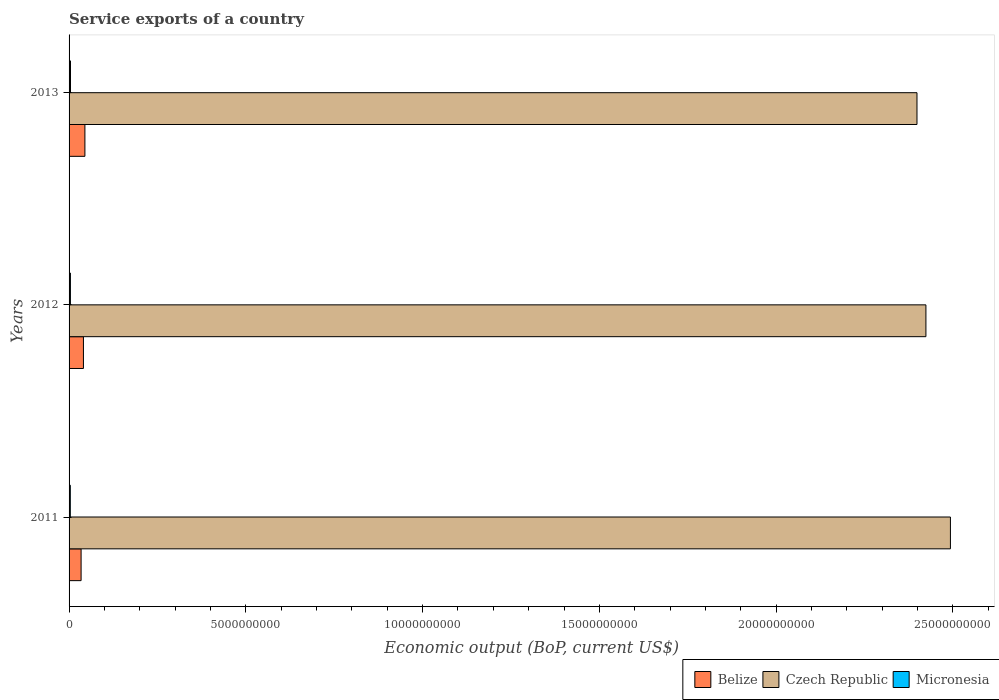How many different coloured bars are there?
Your answer should be very brief. 3. How many groups of bars are there?
Offer a very short reply. 3. Are the number of bars per tick equal to the number of legend labels?
Keep it short and to the point. Yes. Are the number of bars on each tick of the Y-axis equal?
Your answer should be compact. Yes. What is the service exports in Czech Republic in 2011?
Offer a very short reply. 2.49e+1. Across all years, what is the maximum service exports in Czech Republic?
Provide a short and direct response. 2.49e+1. Across all years, what is the minimum service exports in Czech Republic?
Your answer should be very brief. 2.40e+1. What is the total service exports in Micronesia in the graph?
Provide a succinct answer. 1.14e+08. What is the difference between the service exports in Micronesia in 2011 and that in 2012?
Provide a succinct answer. -3.22e+06. What is the difference between the service exports in Micronesia in 2011 and the service exports in Belize in 2013?
Offer a very short reply. -4.13e+08. What is the average service exports in Belize per year?
Your answer should be compact. 3.98e+08. In the year 2011, what is the difference between the service exports in Czech Republic and service exports in Belize?
Your response must be concise. 2.46e+1. In how many years, is the service exports in Czech Republic greater than 2000000000 US$?
Provide a succinct answer. 3. What is the ratio of the service exports in Belize in 2012 to that in 2013?
Provide a succinct answer. 0.91. Is the difference between the service exports in Czech Republic in 2012 and 2013 greater than the difference between the service exports in Belize in 2012 and 2013?
Offer a very short reply. Yes. What is the difference between the highest and the second highest service exports in Czech Republic?
Offer a terse response. 6.93e+08. What is the difference between the highest and the lowest service exports in Czech Republic?
Your answer should be compact. 9.46e+08. Is the sum of the service exports in Belize in 2012 and 2013 greater than the maximum service exports in Czech Republic across all years?
Offer a very short reply. No. What does the 3rd bar from the top in 2012 represents?
Make the answer very short. Belize. What does the 3rd bar from the bottom in 2013 represents?
Give a very brief answer. Micronesia. How many bars are there?
Provide a short and direct response. 9. What is the difference between two consecutive major ticks on the X-axis?
Offer a very short reply. 5.00e+09. Does the graph contain grids?
Provide a succinct answer. No. Where does the legend appear in the graph?
Keep it short and to the point. Bottom right. How are the legend labels stacked?
Your answer should be compact. Horizontal. What is the title of the graph?
Offer a very short reply. Service exports of a country. What is the label or title of the X-axis?
Provide a succinct answer. Economic output (BoP, current US$). What is the label or title of the Y-axis?
Your answer should be very brief. Years. What is the Economic output (BoP, current US$) in Belize in 2011?
Your answer should be compact. 3.40e+08. What is the Economic output (BoP, current US$) of Czech Republic in 2011?
Provide a short and direct response. 2.49e+1. What is the Economic output (BoP, current US$) of Micronesia in 2011?
Ensure brevity in your answer.  3.50e+07. What is the Economic output (BoP, current US$) of Belize in 2012?
Offer a terse response. 4.07e+08. What is the Economic output (BoP, current US$) in Czech Republic in 2012?
Offer a terse response. 2.42e+1. What is the Economic output (BoP, current US$) in Micronesia in 2012?
Give a very brief answer. 3.82e+07. What is the Economic output (BoP, current US$) in Belize in 2013?
Your response must be concise. 4.48e+08. What is the Economic output (BoP, current US$) of Czech Republic in 2013?
Ensure brevity in your answer.  2.40e+1. What is the Economic output (BoP, current US$) in Micronesia in 2013?
Offer a very short reply. 4.05e+07. Across all years, what is the maximum Economic output (BoP, current US$) in Belize?
Keep it short and to the point. 4.48e+08. Across all years, what is the maximum Economic output (BoP, current US$) in Czech Republic?
Make the answer very short. 2.49e+1. Across all years, what is the maximum Economic output (BoP, current US$) of Micronesia?
Provide a succinct answer. 4.05e+07. Across all years, what is the minimum Economic output (BoP, current US$) in Belize?
Your response must be concise. 3.40e+08. Across all years, what is the minimum Economic output (BoP, current US$) in Czech Republic?
Keep it short and to the point. 2.40e+1. Across all years, what is the minimum Economic output (BoP, current US$) in Micronesia?
Ensure brevity in your answer.  3.50e+07. What is the total Economic output (BoP, current US$) in Belize in the graph?
Keep it short and to the point. 1.19e+09. What is the total Economic output (BoP, current US$) in Czech Republic in the graph?
Provide a succinct answer. 7.31e+1. What is the total Economic output (BoP, current US$) of Micronesia in the graph?
Your answer should be compact. 1.14e+08. What is the difference between the Economic output (BoP, current US$) of Belize in 2011 and that in 2012?
Provide a short and direct response. -6.64e+07. What is the difference between the Economic output (BoP, current US$) in Czech Republic in 2011 and that in 2012?
Ensure brevity in your answer.  6.93e+08. What is the difference between the Economic output (BoP, current US$) in Micronesia in 2011 and that in 2012?
Make the answer very short. -3.22e+06. What is the difference between the Economic output (BoP, current US$) of Belize in 2011 and that in 2013?
Provide a succinct answer. -1.08e+08. What is the difference between the Economic output (BoP, current US$) of Czech Republic in 2011 and that in 2013?
Your answer should be compact. 9.46e+08. What is the difference between the Economic output (BoP, current US$) in Micronesia in 2011 and that in 2013?
Offer a very short reply. -5.56e+06. What is the difference between the Economic output (BoP, current US$) in Belize in 2012 and that in 2013?
Offer a very short reply. -4.15e+07. What is the difference between the Economic output (BoP, current US$) in Czech Republic in 2012 and that in 2013?
Provide a short and direct response. 2.53e+08. What is the difference between the Economic output (BoP, current US$) of Micronesia in 2012 and that in 2013?
Make the answer very short. -2.34e+06. What is the difference between the Economic output (BoP, current US$) of Belize in 2011 and the Economic output (BoP, current US$) of Czech Republic in 2012?
Your response must be concise. -2.39e+1. What is the difference between the Economic output (BoP, current US$) of Belize in 2011 and the Economic output (BoP, current US$) of Micronesia in 2012?
Keep it short and to the point. 3.02e+08. What is the difference between the Economic output (BoP, current US$) of Czech Republic in 2011 and the Economic output (BoP, current US$) of Micronesia in 2012?
Offer a very short reply. 2.49e+1. What is the difference between the Economic output (BoP, current US$) in Belize in 2011 and the Economic output (BoP, current US$) in Czech Republic in 2013?
Offer a terse response. -2.36e+1. What is the difference between the Economic output (BoP, current US$) in Belize in 2011 and the Economic output (BoP, current US$) in Micronesia in 2013?
Provide a succinct answer. 3.00e+08. What is the difference between the Economic output (BoP, current US$) in Czech Republic in 2011 and the Economic output (BoP, current US$) in Micronesia in 2013?
Your answer should be compact. 2.49e+1. What is the difference between the Economic output (BoP, current US$) of Belize in 2012 and the Economic output (BoP, current US$) of Czech Republic in 2013?
Your response must be concise. -2.36e+1. What is the difference between the Economic output (BoP, current US$) of Belize in 2012 and the Economic output (BoP, current US$) of Micronesia in 2013?
Your answer should be compact. 3.66e+08. What is the difference between the Economic output (BoP, current US$) of Czech Republic in 2012 and the Economic output (BoP, current US$) of Micronesia in 2013?
Your answer should be compact. 2.42e+1. What is the average Economic output (BoP, current US$) of Belize per year?
Your response must be concise. 3.98e+08. What is the average Economic output (BoP, current US$) in Czech Republic per year?
Offer a terse response. 2.44e+1. What is the average Economic output (BoP, current US$) of Micronesia per year?
Provide a short and direct response. 3.79e+07. In the year 2011, what is the difference between the Economic output (BoP, current US$) of Belize and Economic output (BoP, current US$) of Czech Republic?
Keep it short and to the point. -2.46e+1. In the year 2011, what is the difference between the Economic output (BoP, current US$) in Belize and Economic output (BoP, current US$) in Micronesia?
Your answer should be very brief. 3.05e+08. In the year 2011, what is the difference between the Economic output (BoP, current US$) of Czech Republic and Economic output (BoP, current US$) of Micronesia?
Your answer should be compact. 2.49e+1. In the year 2012, what is the difference between the Economic output (BoP, current US$) of Belize and Economic output (BoP, current US$) of Czech Republic?
Your answer should be very brief. -2.38e+1. In the year 2012, what is the difference between the Economic output (BoP, current US$) of Belize and Economic output (BoP, current US$) of Micronesia?
Make the answer very short. 3.68e+08. In the year 2012, what is the difference between the Economic output (BoP, current US$) of Czech Republic and Economic output (BoP, current US$) of Micronesia?
Your answer should be very brief. 2.42e+1. In the year 2013, what is the difference between the Economic output (BoP, current US$) of Belize and Economic output (BoP, current US$) of Czech Republic?
Keep it short and to the point. -2.35e+1. In the year 2013, what is the difference between the Economic output (BoP, current US$) of Belize and Economic output (BoP, current US$) of Micronesia?
Give a very brief answer. 4.08e+08. In the year 2013, what is the difference between the Economic output (BoP, current US$) in Czech Republic and Economic output (BoP, current US$) in Micronesia?
Keep it short and to the point. 2.39e+1. What is the ratio of the Economic output (BoP, current US$) in Belize in 2011 to that in 2012?
Your answer should be compact. 0.84. What is the ratio of the Economic output (BoP, current US$) of Czech Republic in 2011 to that in 2012?
Make the answer very short. 1.03. What is the ratio of the Economic output (BoP, current US$) in Micronesia in 2011 to that in 2012?
Make the answer very short. 0.92. What is the ratio of the Economic output (BoP, current US$) of Belize in 2011 to that in 2013?
Your answer should be very brief. 0.76. What is the ratio of the Economic output (BoP, current US$) of Czech Republic in 2011 to that in 2013?
Give a very brief answer. 1.04. What is the ratio of the Economic output (BoP, current US$) in Micronesia in 2011 to that in 2013?
Offer a very short reply. 0.86. What is the ratio of the Economic output (BoP, current US$) in Belize in 2012 to that in 2013?
Keep it short and to the point. 0.91. What is the ratio of the Economic output (BoP, current US$) in Czech Republic in 2012 to that in 2013?
Give a very brief answer. 1.01. What is the ratio of the Economic output (BoP, current US$) in Micronesia in 2012 to that in 2013?
Your response must be concise. 0.94. What is the difference between the highest and the second highest Economic output (BoP, current US$) of Belize?
Give a very brief answer. 4.15e+07. What is the difference between the highest and the second highest Economic output (BoP, current US$) of Czech Republic?
Keep it short and to the point. 6.93e+08. What is the difference between the highest and the second highest Economic output (BoP, current US$) of Micronesia?
Keep it short and to the point. 2.34e+06. What is the difference between the highest and the lowest Economic output (BoP, current US$) in Belize?
Your response must be concise. 1.08e+08. What is the difference between the highest and the lowest Economic output (BoP, current US$) in Czech Republic?
Offer a very short reply. 9.46e+08. What is the difference between the highest and the lowest Economic output (BoP, current US$) of Micronesia?
Offer a terse response. 5.56e+06. 